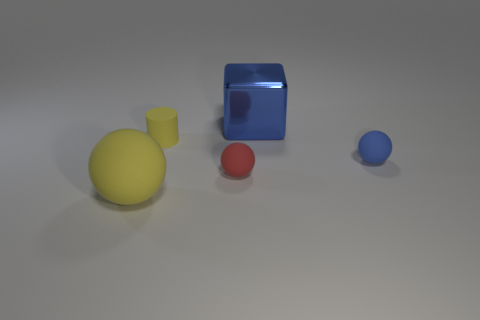Are there any other things that have the same material as the big blue block?
Offer a very short reply. No. Are there the same number of big blue cubes that are to the left of the tiny cylinder and small balls that are right of the big blue metal thing?
Offer a terse response. No. There is a matte thing on the right side of the large metal object; does it have the same size as the blue object that is behind the blue sphere?
Offer a very short reply. No. What number of other large things are the same color as the shiny thing?
Make the answer very short. 0. There is a large ball that is the same color as the matte cylinder; what is its material?
Provide a short and direct response. Rubber. Is the number of red matte balls on the right side of the yellow ball greater than the number of tiny gray rubber objects?
Make the answer very short. Yes. Does the small blue object have the same shape as the big yellow matte thing?
Offer a very short reply. Yes. How many big spheres are made of the same material as the large yellow thing?
Your answer should be very brief. 0. What size is the yellow rubber object that is the same shape as the red thing?
Offer a very short reply. Large. Do the red matte sphere and the matte cylinder have the same size?
Make the answer very short. Yes. 